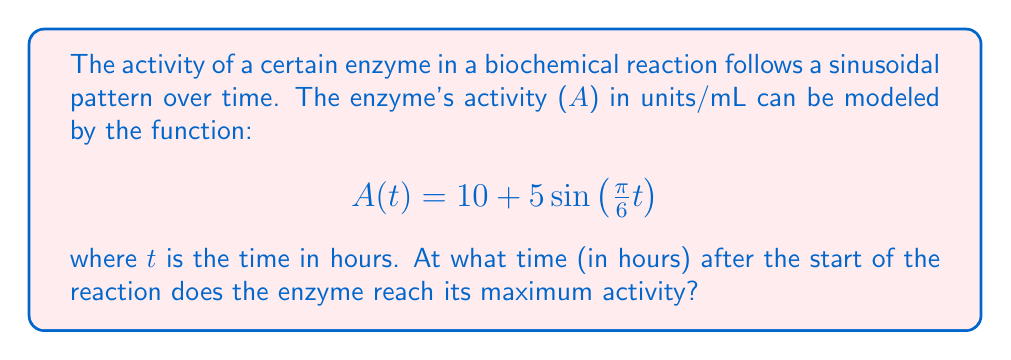Provide a solution to this math problem. To find the time when the enzyme reaches its maximum activity, we need to determine when the sine function reaches its peak. Let's approach this step-by-step:

1) The general form of a sine function is:
   $$f(t) = a + b\sin(ct + d)$$
   where a is the vertical shift, b is the amplitude, c is the angular frequency, and d is the phase shift.

2) In our case:
   $$A(t) = 10 + 5\sin(\frac{\pi}{6}t)$$
   So, a = 10, b = 5, c = $\frac{\pi}{6}$, and d = 0.

3) The sine function reaches its maximum value of 1 when its argument is $\frac{\pi}{2}$ (or 90°).

4) We need to solve:
   $$\frac{\pi}{6}t = \frac{\pi}{2}$$

5) Solving for t:
   $$t = \frac{\pi}{2} \cdot \frac{6}{\pi} = 3$$

6) Therefore, the enzyme reaches its maximum activity 3 hours after the start of the reaction.

7) We can verify this by calculating the period of the function:
   Period = $\frac{2\pi}{c} = \frac{2\pi}{\frac{\pi}{6}} = 12$ hours

   This means the function repeats every 12 hours, and the maximum occurs at 1/4 of the period, which is indeed 3 hours.
Answer: 3 hours 